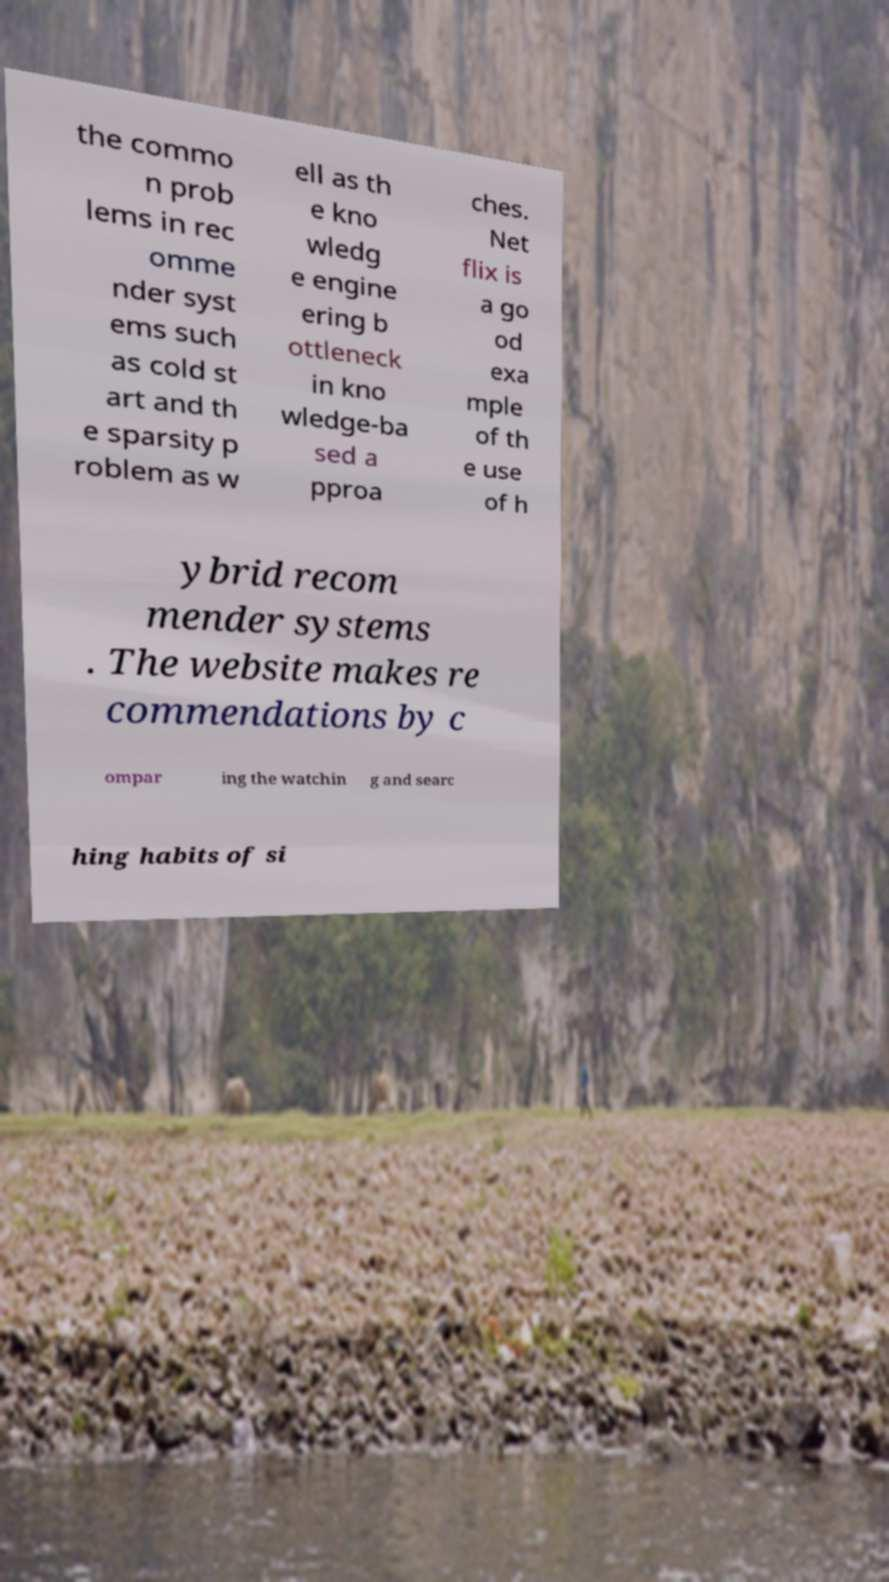Can you accurately transcribe the text from the provided image for me? the commo n prob lems in rec omme nder syst ems such as cold st art and th e sparsity p roblem as w ell as th e kno wledg e engine ering b ottleneck in kno wledge-ba sed a pproa ches. Net flix is a go od exa mple of th e use of h ybrid recom mender systems . The website makes re commendations by c ompar ing the watchin g and searc hing habits of si 